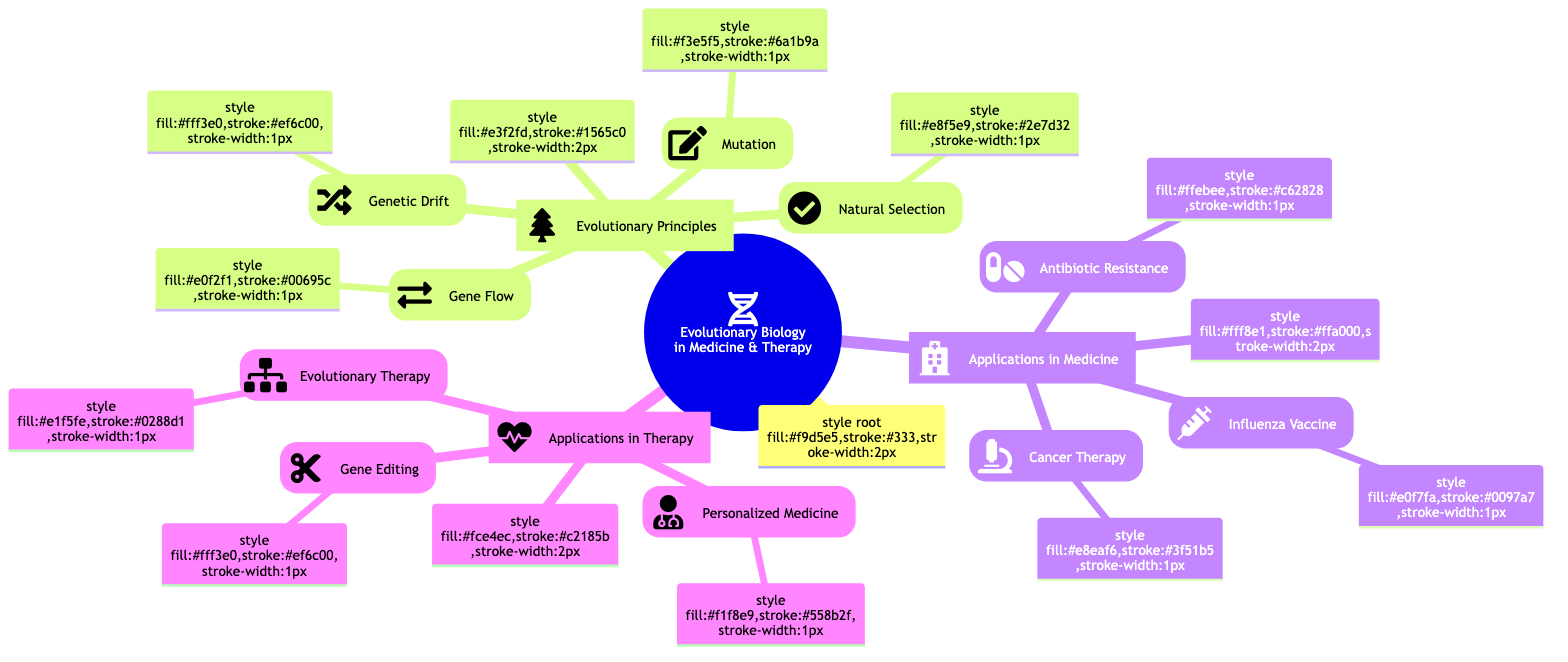What are the four main evolutionary principles? The four main evolutionary principles listed are Natural Selection, Genetic Drift, Mutation, and Gene Flow. These can be found in the "Evolutionary Principles" section of the diagram.
Answer: Natural Selection, Genetic Drift, Mutation, Gene Flow How many applications in medicine are mentioned? There are three applications listed in the "Applications in Medicine" section, which are Antibiotic Resistance, Cancer Therapy, and Influenza Vaccine Development. Counting the entries reveals three distinct applications.
Answer: 3 What technology is associated with Gene Editing? The diagram specifies CRISPR-Cas9 as the technology related to Gene Editing found in the "Applications in Therapy" section. This specific term represents a method of genetic modification.
Answer: CRISPR-Cas9 What example is given for Natural Selection? The diagram cites antibiotic resistance in bacteria as an example of Natural Selection under the corresponding section. This connection demonstrates a real-world representation of the principle.
Answer: Antibiotic resistance in bacteria Which organization is mentioned in relation to influenza vaccine development? The World Health Organization (WHO) is mentioned in the diagram as an organization involved in predicting flu virus strains for vaccine development. This information is found in the "Influenza Vaccine Development" subsection.
Answer: World Health Organization (WHO) Explain how cancer cells evolve resistance to treatment. The diagram explains that cancer cells evolve resistance to chemotherapeutic agents as part of Cancer Therapy, illustrating a challenge in treating cancers effectively. This shows how evolutionary principles apply directly to the challenges in medicine.
Answer: Cancer cells evolve resistance to chemotherapeutic agents What is the purpose of Personalized Medicine? The purpose of Personalized Medicine, as indicated in the diagram, is to tailor medical treatment to individual genetic profiles, ensuring treatments are more effective for each patient based on their unique genetics.
Answer: Tailoring medical treatment to individual genetic profiles How many sections are there in the Mind Map? The diagram consists of three main sections: Evolutionary Principles, Applications in Medicine, and Applications in Therapy. Looking at the root structure reveals these distinct areas of focus.
Answer: 3 What is an example of an application of Evolutionary Therapy? The diagram mentions adaptive therapy in cancer as an example of Evolutionary Therapy. This serves to illustrate a specific therapeutic approach informed by evolutionary principles.
Answer: Adaptive therapy in cancer 